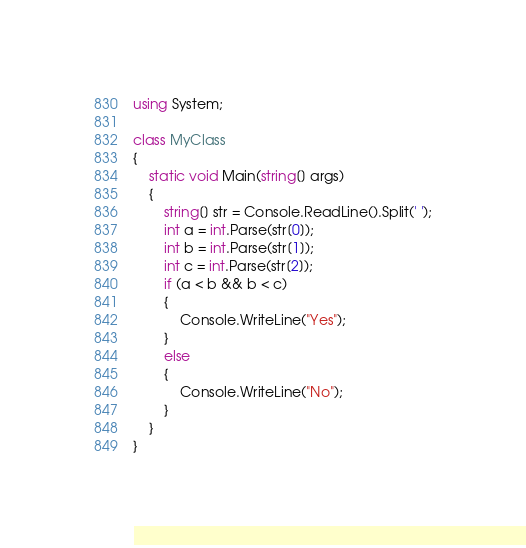Convert code to text. <code><loc_0><loc_0><loc_500><loc_500><_C#_>using System;

class MyClass
{
    static void Main(string[] args)
    {
        string[] str = Console.ReadLine().Split(' ');
        int a = int.Parse(str[0]);
        int b = int.Parse(str[1]);
        int c = int.Parse(str[2]);
        if (a < b && b < c)
        {
            Console.WriteLine("Yes");
        }
        else
        {
            Console.WriteLine("No");
        }
    }
}
</code> 